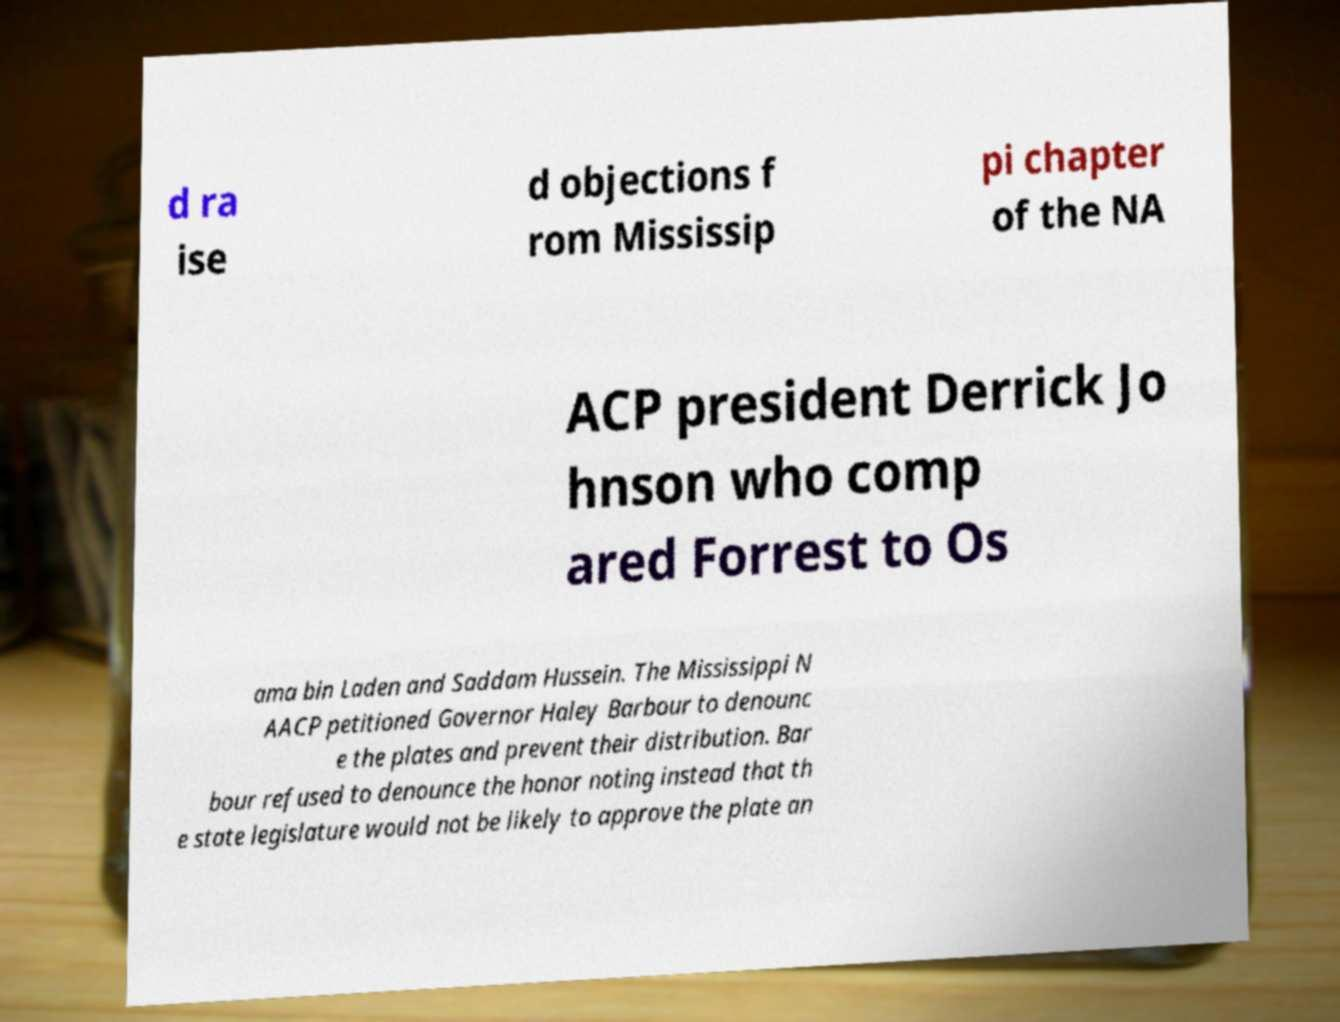Can you read and provide the text displayed in the image?This photo seems to have some interesting text. Can you extract and type it out for me? d ra ise d objections f rom Mississip pi chapter of the NA ACP president Derrick Jo hnson who comp ared Forrest to Os ama bin Laden and Saddam Hussein. The Mississippi N AACP petitioned Governor Haley Barbour to denounc e the plates and prevent their distribution. Bar bour refused to denounce the honor noting instead that th e state legislature would not be likely to approve the plate an 